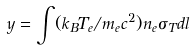<formula> <loc_0><loc_0><loc_500><loc_500>y = \int ( k _ { B } T _ { e } / m _ { e } c ^ { 2 } ) n _ { e } \sigma _ { T } d l</formula> 